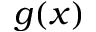<formula> <loc_0><loc_0><loc_500><loc_500>g ( x )</formula> 